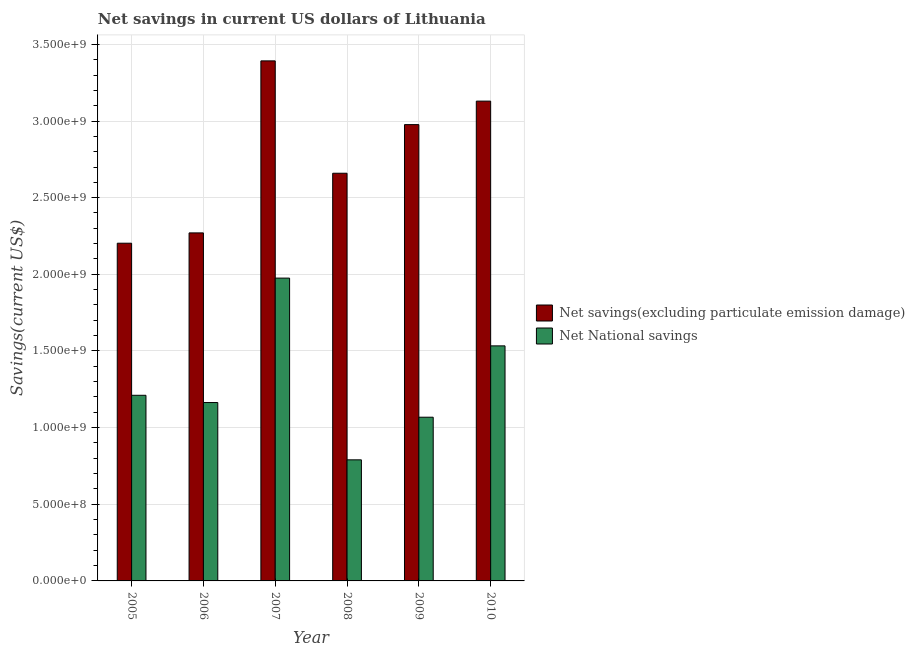Are the number of bars per tick equal to the number of legend labels?
Your answer should be very brief. Yes. How many bars are there on the 3rd tick from the left?
Provide a short and direct response. 2. What is the label of the 5th group of bars from the left?
Offer a very short reply. 2009. What is the net savings(excluding particulate emission damage) in 2009?
Provide a succinct answer. 2.98e+09. Across all years, what is the maximum net national savings?
Give a very brief answer. 1.98e+09. Across all years, what is the minimum net national savings?
Ensure brevity in your answer.  7.90e+08. What is the total net savings(excluding particulate emission damage) in the graph?
Give a very brief answer. 1.66e+1. What is the difference between the net national savings in 2005 and that in 2006?
Give a very brief answer. 4.73e+07. What is the difference between the net savings(excluding particulate emission damage) in 2008 and the net national savings in 2007?
Provide a succinct answer. -7.33e+08. What is the average net savings(excluding particulate emission damage) per year?
Give a very brief answer. 2.77e+09. In how many years, is the net savings(excluding particulate emission damage) greater than 700000000 US$?
Ensure brevity in your answer.  6. What is the ratio of the net national savings in 2007 to that in 2009?
Offer a terse response. 1.85. Is the net national savings in 2007 less than that in 2008?
Your answer should be compact. No. Is the difference between the net national savings in 2007 and 2009 greater than the difference between the net savings(excluding particulate emission damage) in 2007 and 2009?
Offer a terse response. No. What is the difference between the highest and the second highest net savings(excluding particulate emission damage)?
Provide a short and direct response. 2.63e+08. What is the difference between the highest and the lowest net savings(excluding particulate emission damage)?
Offer a very short reply. 1.19e+09. What does the 1st bar from the left in 2008 represents?
Make the answer very short. Net savings(excluding particulate emission damage). What does the 1st bar from the right in 2007 represents?
Offer a terse response. Net National savings. How many years are there in the graph?
Offer a terse response. 6. Are the values on the major ticks of Y-axis written in scientific E-notation?
Provide a short and direct response. Yes. Does the graph contain grids?
Offer a terse response. Yes. Where does the legend appear in the graph?
Offer a terse response. Center right. What is the title of the graph?
Give a very brief answer. Net savings in current US dollars of Lithuania. Does "Working capital" appear as one of the legend labels in the graph?
Your answer should be compact. No. What is the label or title of the Y-axis?
Make the answer very short. Savings(current US$). What is the Savings(current US$) in Net savings(excluding particulate emission damage) in 2005?
Your response must be concise. 2.20e+09. What is the Savings(current US$) of Net National savings in 2005?
Offer a very short reply. 1.21e+09. What is the Savings(current US$) in Net savings(excluding particulate emission damage) in 2006?
Provide a succinct answer. 2.27e+09. What is the Savings(current US$) of Net National savings in 2006?
Your answer should be very brief. 1.16e+09. What is the Savings(current US$) in Net savings(excluding particulate emission damage) in 2007?
Ensure brevity in your answer.  3.39e+09. What is the Savings(current US$) of Net National savings in 2007?
Offer a very short reply. 1.98e+09. What is the Savings(current US$) of Net savings(excluding particulate emission damage) in 2008?
Your answer should be very brief. 2.66e+09. What is the Savings(current US$) in Net National savings in 2008?
Provide a succinct answer. 7.90e+08. What is the Savings(current US$) of Net savings(excluding particulate emission damage) in 2009?
Your response must be concise. 2.98e+09. What is the Savings(current US$) of Net National savings in 2009?
Give a very brief answer. 1.07e+09. What is the Savings(current US$) in Net savings(excluding particulate emission damage) in 2010?
Give a very brief answer. 3.13e+09. What is the Savings(current US$) of Net National savings in 2010?
Keep it short and to the point. 1.53e+09. Across all years, what is the maximum Savings(current US$) of Net savings(excluding particulate emission damage)?
Your response must be concise. 3.39e+09. Across all years, what is the maximum Savings(current US$) in Net National savings?
Your answer should be very brief. 1.98e+09. Across all years, what is the minimum Savings(current US$) of Net savings(excluding particulate emission damage)?
Ensure brevity in your answer.  2.20e+09. Across all years, what is the minimum Savings(current US$) of Net National savings?
Make the answer very short. 7.90e+08. What is the total Savings(current US$) of Net savings(excluding particulate emission damage) in the graph?
Your answer should be compact. 1.66e+1. What is the total Savings(current US$) in Net National savings in the graph?
Offer a terse response. 7.74e+09. What is the difference between the Savings(current US$) of Net savings(excluding particulate emission damage) in 2005 and that in 2006?
Provide a short and direct response. -6.73e+07. What is the difference between the Savings(current US$) of Net National savings in 2005 and that in 2006?
Make the answer very short. 4.73e+07. What is the difference between the Savings(current US$) in Net savings(excluding particulate emission damage) in 2005 and that in 2007?
Offer a very short reply. -1.19e+09. What is the difference between the Savings(current US$) in Net National savings in 2005 and that in 2007?
Give a very brief answer. -7.64e+08. What is the difference between the Savings(current US$) in Net savings(excluding particulate emission damage) in 2005 and that in 2008?
Offer a terse response. -4.56e+08. What is the difference between the Savings(current US$) in Net National savings in 2005 and that in 2008?
Keep it short and to the point. 4.21e+08. What is the difference between the Savings(current US$) of Net savings(excluding particulate emission damage) in 2005 and that in 2009?
Your answer should be compact. -7.74e+08. What is the difference between the Savings(current US$) in Net National savings in 2005 and that in 2009?
Your answer should be compact. 1.43e+08. What is the difference between the Savings(current US$) of Net savings(excluding particulate emission damage) in 2005 and that in 2010?
Offer a terse response. -9.27e+08. What is the difference between the Savings(current US$) in Net National savings in 2005 and that in 2010?
Offer a terse response. -3.22e+08. What is the difference between the Savings(current US$) of Net savings(excluding particulate emission damage) in 2006 and that in 2007?
Offer a very short reply. -1.12e+09. What is the difference between the Savings(current US$) of Net National savings in 2006 and that in 2007?
Offer a very short reply. -8.12e+08. What is the difference between the Savings(current US$) in Net savings(excluding particulate emission damage) in 2006 and that in 2008?
Your answer should be compact. -3.89e+08. What is the difference between the Savings(current US$) in Net National savings in 2006 and that in 2008?
Your response must be concise. 3.74e+08. What is the difference between the Savings(current US$) of Net savings(excluding particulate emission damage) in 2006 and that in 2009?
Your answer should be very brief. -7.06e+08. What is the difference between the Savings(current US$) in Net National savings in 2006 and that in 2009?
Your answer should be very brief. 9.57e+07. What is the difference between the Savings(current US$) in Net savings(excluding particulate emission damage) in 2006 and that in 2010?
Your answer should be very brief. -8.60e+08. What is the difference between the Savings(current US$) in Net National savings in 2006 and that in 2010?
Make the answer very short. -3.70e+08. What is the difference between the Savings(current US$) of Net savings(excluding particulate emission damage) in 2007 and that in 2008?
Offer a terse response. 7.33e+08. What is the difference between the Savings(current US$) of Net National savings in 2007 and that in 2008?
Ensure brevity in your answer.  1.19e+09. What is the difference between the Savings(current US$) in Net savings(excluding particulate emission damage) in 2007 and that in 2009?
Your response must be concise. 4.16e+08. What is the difference between the Savings(current US$) in Net National savings in 2007 and that in 2009?
Give a very brief answer. 9.07e+08. What is the difference between the Savings(current US$) in Net savings(excluding particulate emission damage) in 2007 and that in 2010?
Offer a terse response. 2.63e+08. What is the difference between the Savings(current US$) of Net National savings in 2007 and that in 2010?
Your response must be concise. 4.42e+08. What is the difference between the Savings(current US$) of Net savings(excluding particulate emission damage) in 2008 and that in 2009?
Provide a short and direct response. -3.17e+08. What is the difference between the Savings(current US$) in Net National savings in 2008 and that in 2009?
Your answer should be very brief. -2.78e+08. What is the difference between the Savings(current US$) of Net savings(excluding particulate emission damage) in 2008 and that in 2010?
Provide a short and direct response. -4.70e+08. What is the difference between the Savings(current US$) in Net National savings in 2008 and that in 2010?
Keep it short and to the point. -7.43e+08. What is the difference between the Savings(current US$) in Net savings(excluding particulate emission damage) in 2009 and that in 2010?
Your answer should be compact. -1.53e+08. What is the difference between the Savings(current US$) in Net National savings in 2009 and that in 2010?
Provide a short and direct response. -4.65e+08. What is the difference between the Savings(current US$) of Net savings(excluding particulate emission damage) in 2005 and the Savings(current US$) of Net National savings in 2006?
Offer a terse response. 1.04e+09. What is the difference between the Savings(current US$) of Net savings(excluding particulate emission damage) in 2005 and the Savings(current US$) of Net National savings in 2007?
Your response must be concise. 2.28e+08. What is the difference between the Savings(current US$) of Net savings(excluding particulate emission damage) in 2005 and the Savings(current US$) of Net National savings in 2008?
Provide a succinct answer. 1.41e+09. What is the difference between the Savings(current US$) of Net savings(excluding particulate emission damage) in 2005 and the Savings(current US$) of Net National savings in 2009?
Provide a succinct answer. 1.14e+09. What is the difference between the Savings(current US$) of Net savings(excluding particulate emission damage) in 2005 and the Savings(current US$) of Net National savings in 2010?
Provide a succinct answer. 6.70e+08. What is the difference between the Savings(current US$) in Net savings(excluding particulate emission damage) in 2006 and the Savings(current US$) in Net National savings in 2007?
Your response must be concise. 2.95e+08. What is the difference between the Savings(current US$) of Net savings(excluding particulate emission damage) in 2006 and the Savings(current US$) of Net National savings in 2008?
Your response must be concise. 1.48e+09. What is the difference between the Savings(current US$) in Net savings(excluding particulate emission damage) in 2006 and the Savings(current US$) in Net National savings in 2009?
Offer a very short reply. 1.20e+09. What is the difference between the Savings(current US$) in Net savings(excluding particulate emission damage) in 2006 and the Savings(current US$) in Net National savings in 2010?
Offer a very short reply. 7.37e+08. What is the difference between the Savings(current US$) in Net savings(excluding particulate emission damage) in 2007 and the Savings(current US$) in Net National savings in 2008?
Keep it short and to the point. 2.60e+09. What is the difference between the Savings(current US$) in Net savings(excluding particulate emission damage) in 2007 and the Savings(current US$) in Net National savings in 2009?
Ensure brevity in your answer.  2.32e+09. What is the difference between the Savings(current US$) of Net savings(excluding particulate emission damage) in 2007 and the Savings(current US$) of Net National savings in 2010?
Offer a terse response. 1.86e+09. What is the difference between the Savings(current US$) of Net savings(excluding particulate emission damage) in 2008 and the Savings(current US$) of Net National savings in 2009?
Your response must be concise. 1.59e+09. What is the difference between the Savings(current US$) in Net savings(excluding particulate emission damage) in 2008 and the Savings(current US$) in Net National savings in 2010?
Provide a succinct answer. 1.13e+09. What is the difference between the Savings(current US$) of Net savings(excluding particulate emission damage) in 2009 and the Savings(current US$) of Net National savings in 2010?
Offer a terse response. 1.44e+09. What is the average Savings(current US$) of Net savings(excluding particulate emission damage) per year?
Offer a terse response. 2.77e+09. What is the average Savings(current US$) in Net National savings per year?
Your response must be concise. 1.29e+09. In the year 2005, what is the difference between the Savings(current US$) in Net savings(excluding particulate emission damage) and Savings(current US$) in Net National savings?
Provide a succinct answer. 9.92e+08. In the year 2006, what is the difference between the Savings(current US$) in Net savings(excluding particulate emission damage) and Savings(current US$) in Net National savings?
Offer a very short reply. 1.11e+09. In the year 2007, what is the difference between the Savings(current US$) in Net savings(excluding particulate emission damage) and Savings(current US$) in Net National savings?
Ensure brevity in your answer.  1.42e+09. In the year 2008, what is the difference between the Savings(current US$) in Net savings(excluding particulate emission damage) and Savings(current US$) in Net National savings?
Your answer should be compact. 1.87e+09. In the year 2009, what is the difference between the Savings(current US$) of Net savings(excluding particulate emission damage) and Savings(current US$) of Net National savings?
Give a very brief answer. 1.91e+09. In the year 2010, what is the difference between the Savings(current US$) of Net savings(excluding particulate emission damage) and Savings(current US$) of Net National savings?
Offer a terse response. 1.60e+09. What is the ratio of the Savings(current US$) of Net savings(excluding particulate emission damage) in 2005 to that in 2006?
Ensure brevity in your answer.  0.97. What is the ratio of the Savings(current US$) in Net National savings in 2005 to that in 2006?
Keep it short and to the point. 1.04. What is the ratio of the Savings(current US$) of Net savings(excluding particulate emission damage) in 2005 to that in 2007?
Give a very brief answer. 0.65. What is the ratio of the Savings(current US$) in Net National savings in 2005 to that in 2007?
Your response must be concise. 0.61. What is the ratio of the Savings(current US$) of Net savings(excluding particulate emission damage) in 2005 to that in 2008?
Give a very brief answer. 0.83. What is the ratio of the Savings(current US$) of Net National savings in 2005 to that in 2008?
Provide a short and direct response. 1.53. What is the ratio of the Savings(current US$) of Net savings(excluding particulate emission damage) in 2005 to that in 2009?
Your answer should be compact. 0.74. What is the ratio of the Savings(current US$) in Net National savings in 2005 to that in 2009?
Offer a terse response. 1.13. What is the ratio of the Savings(current US$) in Net savings(excluding particulate emission damage) in 2005 to that in 2010?
Provide a short and direct response. 0.7. What is the ratio of the Savings(current US$) in Net National savings in 2005 to that in 2010?
Give a very brief answer. 0.79. What is the ratio of the Savings(current US$) of Net savings(excluding particulate emission damage) in 2006 to that in 2007?
Keep it short and to the point. 0.67. What is the ratio of the Savings(current US$) in Net National savings in 2006 to that in 2007?
Your answer should be very brief. 0.59. What is the ratio of the Savings(current US$) of Net savings(excluding particulate emission damage) in 2006 to that in 2008?
Provide a short and direct response. 0.85. What is the ratio of the Savings(current US$) in Net National savings in 2006 to that in 2008?
Your answer should be very brief. 1.47. What is the ratio of the Savings(current US$) in Net savings(excluding particulate emission damage) in 2006 to that in 2009?
Make the answer very short. 0.76. What is the ratio of the Savings(current US$) of Net National savings in 2006 to that in 2009?
Make the answer very short. 1.09. What is the ratio of the Savings(current US$) in Net savings(excluding particulate emission damage) in 2006 to that in 2010?
Offer a very short reply. 0.73. What is the ratio of the Savings(current US$) in Net National savings in 2006 to that in 2010?
Provide a short and direct response. 0.76. What is the ratio of the Savings(current US$) in Net savings(excluding particulate emission damage) in 2007 to that in 2008?
Offer a terse response. 1.28. What is the ratio of the Savings(current US$) of Net National savings in 2007 to that in 2008?
Offer a very short reply. 2.5. What is the ratio of the Savings(current US$) of Net savings(excluding particulate emission damage) in 2007 to that in 2009?
Offer a terse response. 1.14. What is the ratio of the Savings(current US$) in Net National savings in 2007 to that in 2009?
Ensure brevity in your answer.  1.85. What is the ratio of the Savings(current US$) in Net savings(excluding particulate emission damage) in 2007 to that in 2010?
Keep it short and to the point. 1.08. What is the ratio of the Savings(current US$) in Net National savings in 2007 to that in 2010?
Keep it short and to the point. 1.29. What is the ratio of the Savings(current US$) in Net savings(excluding particulate emission damage) in 2008 to that in 2009?
Your answer should be very brief. 0.89. What is the ratio of the Savings(current US$) in Net National savings in 2008 to that in 2009?
Make the answer very short. 0.74. What is the ratio of the Savings(current US$) of Net savings(excluding particulate emission damage) in 2008 to that in 2010?
Your response must be concise. 0.85. What is the ratio of the Savings(current US$) of Net National savings in 2008 to that in 2010?
Your response must be concise. 0.52. What is the ratio of the Savings(current US$) in Net savings(excluding particulate emission damage) in 2009 to that in 2010?
Ensure brevity in your answer.  0.95. What is the ratio of the Savings(current US$) of Net National savings in 2009 to that in 2010?
Provide a succinct answer. 0.7. What is the difference between the highest and the second highest Savings(current US$) in Net savings(excluding particulate emission damage)?
Your answer should be compact. 2.63e+08. What is the difference between the highest and the second highest Savings(current US$) in Net National savings?
Ensure brevity in your answer.  4.42e+08. What is the difference between the highest and the lowest Savings(current US$) of Net savings(excluding particulate emission damage)?
Offer a very short reply. 1.19e+09. What is the difference between the highest and the lowest Savings(current US$) in Net National savings?
Provide a short and direct response. 1.19e+09. 